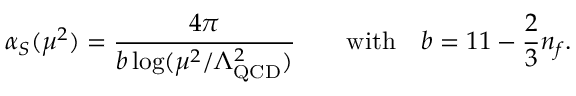<formula> <loc_0><loc_0><loc_500><loc_500>\alpha _ { S } ( \mu ^ { 2 } ) = { \frac { 4 \pi } { b \log ( \mu ^ { 2 } / \Lambda _ { Q C D } ^ { 2 } ) } } \quad w i t h \quad b = 1 1 - { \frac { 2 } { 3 } } n _ { f } .</formula> 